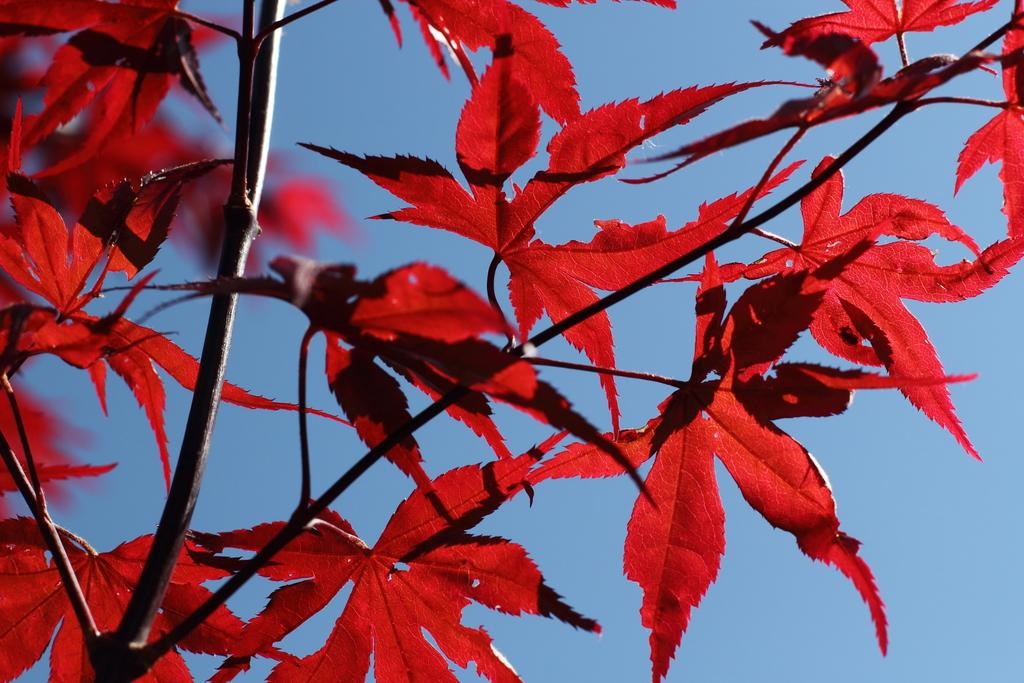What type of living organism can be seen in the image? There is a plant in the image. What is unique about the plant's appearance? The plant has red color leaves. What is visible at the top of the image? The sky is visible at the top of the image. What type of addition problem can be solved using the coil in the image? There is no coil present in the image, and therefore no addition problem can be solved using it. 